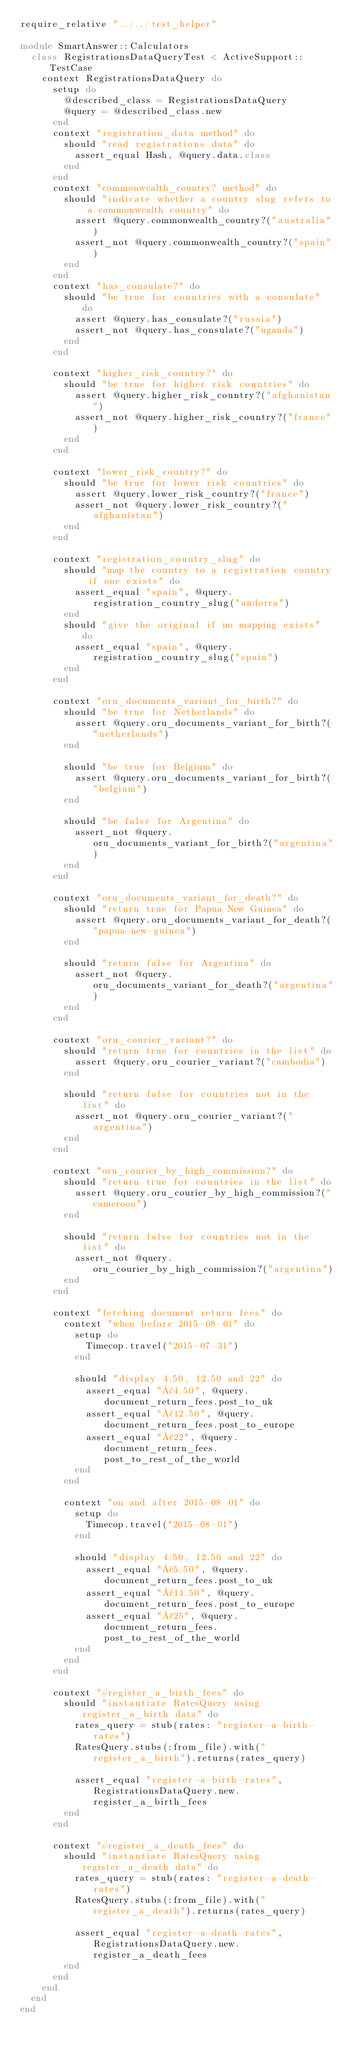Convert code to text. <code><loc_0><loc_0><loc_500><loc_500><_Ruby_>require_relative "../../test_helper"

module SmartAnswer::Calculators
  class RegistrationsDataQueryTest < ActiveSupport::TestCase
    context RegistrationsDataQuery do
      setup do
        @described_class = RegistrationsDataQuery
        @query = @described_class.new
      end
      context "registration_data method" do
        should "read registrations data" do
          assert_equal Hash, @query.data.class
        end
      end
      context "commonwealth_country? method" do
        should "indicate whether a country slug refers to a commonwealth country" do
          assert @query.commonwealth_country?("australia")
          assert_not @query.commonwealth_country?("spain")
        end
      end
      context "has_consulate?" do
        should "be true for countries with a consulate" do
          assert @query.has_consulate?("russia")
          assert_not @query.has_consulate?("uganda")
        end
      end

      context "higher_risk_country?" do
        should "be true for higher risk countries" do
          assert @query.higher_risk_country?("afghanistan")
          assert_not @query.higher_risk_country?("france")
        end
      end

      context "lower_risk_country?" do
        should "be true for lower risk countries" do
          assert @query.lower_risk_country?("france")
          assert_not @query.lower_risk_country?("afghanistan")
        end
      end

      context "registration_country_slug" do
        should "map the country to a registration country if one exists" do
          assert_equal "spain", @query.registration_country_slug("andorra")
        end
        should "give the original if no mapping exists" do
          assert_equal "spain", @query.registration_country_slug("spain")
        end
      end

      context "oru_documents_variant_for_birth?" do
        should "be true for Netherlands" do
          assert @query.oru_documents_variant_for_birth?("netherlands")
        end

        should "be true for Belgium" do
          assert @query.oru_documents_variant_for_birth?("belgium")
        end

        should "be false for Argentina" do
          assert_not @query.oru_documents_variant_for_birth?("argentina")
        end
      end

      context "oru_documents_variant_for_death?" do
        should "return true for Papua New Guinea" do
          assert @query.oru_documents_variant_for_death?("papua-new-guinea")
        end

        should "return false for Argentina" do
          assert_not @query.oru_documents_variant_for_death?("argentina")
        end
      end

      context "oru_courier_variant?" do
        should "return true for countries in the list" do
          assert @query.oru_courier_variant?("cambodia")
        end

        should "return false for countries not in the list" do
          assert_not @query.oru_courier_variant?("argentina")
        end
      end

      context "oru_courier_by_high_commission?" do
        should "return true for countries in the list" do
          assert @query.oru_courier_by_high_commission?("cameroon")
        end

        should "return false for countries not in the list" do
          assert_not @query.oru_courier_by_high_commission?("argentina")
        end
      end

      context "fetching document return fees" do
        context "when before 2015-08-01" do
          setup do
            Timecop.travel("2015-07-31")
          end

          should "display 4.50, 12.50 and 22" do
            assert_equal "£4.50", @query.document_return_fees.post_to_uk
            assert_equal "£12.50", @query.document_return_fees.post_to_europe
            assert_equal "£22", @query.document_return_fees.post_to_rest_of_the_world
          end
        end

        context "on and after 2015-08-01" do
          setup do
            Timecop.travel("2015-08-01")
          end

          should "display 4.50, 12.50 and 22" do
            assert_equal "£5.50", @query.document_return_fees.post_to_uk
            assert_equal "£14.50", @query.document_return_fees.post_to_europe
            assert_equal "£25", @query.document_return_fees.post_to_rest_of_the_world
          end
        end
      end

      context "#register_a_birth_fees" do
        should "instantiate RatesQuery using register_a_birth data" do
          rates_query = stub(rates: "register-a-birth-rates")
          RatesQuery.stubs(:from_file).with("register_a_birth").returns(rates_query)

          assert_equal "register-a-birth-rates", RegistrationsDataQuery.new.register_a_birth_fees
        end
      end

      context "#register_a_death_fees" do
        should "instantiate RatesQuery using register_a_death data" do
          rates_query = stub(rates: "register-a-death-rates")
          RatesQuery.stubs(:from_file).with("register_a_death").returns(rates_query)

          assert_equal "register-a-death-rates", RegistrationsDataQuery.new.register_a_death_fees
        end
      end
    end
  end
end
</code> 